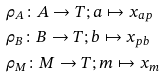Convert formula to latex. <formula><loc_0><loc_0><loc_500><loc_500>& \rho _ { A } \colon A \to T ; a \mapsto x _ { a p } \\ & \rho _ { B } \colon B \to T ; b \mapsto x _ { p b } \\ & \rho _ { M } \colon M \to T ; m \mapsto x _ { m }</formula> 